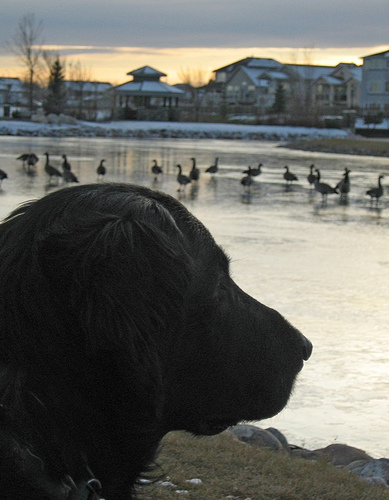<image>
Is there a ducks next to the dog? No. The ducks is not positioned next to the dog. They are located in different areas of the scene. Is there a dog on the water? No. The dog is not positioned on the water. They may be near each other, but the dog is not supported by or resting on top of the water. 